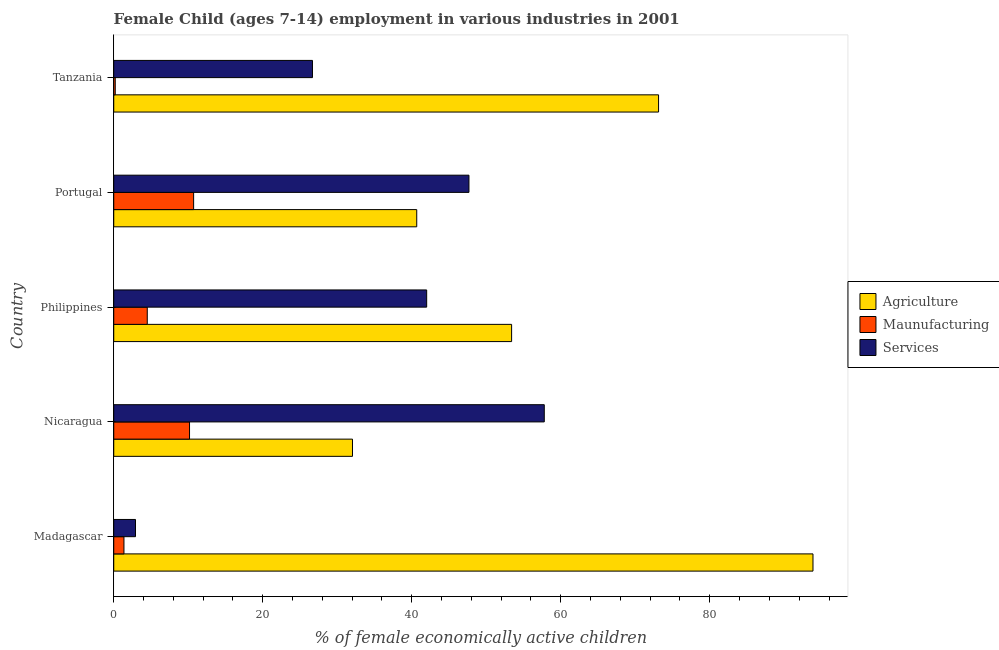Are the number of bars per tick equal to the number of legend labels?
Ensure brevity in your answer.  Yes. Are the number of bars on each tick of the Y-axis equal?
Ensure brevity in your answer.  Yes. What is the label of the 1st group of bars from the top?
Give a very brief answer. Tanzania. In how many cases, is the number of bars for a given country not equal to the number of legend labels?
Ensure brevity in your answer.  0. What is the percentage of economically active children in manufacturing in Portugal?
Ensure brevity in your answer.  10.72. Across all countries, what is the maximum percentage of economically active children in manufacturing?
Offer a very short reply. 10.72. Across all countries, what is the minimum percentage of economically active children in agriculture?
Ensure brevity in your answer.  32.04. In which country was the percentage of economically active children in agriculture maximum?
Give a very brief answer. Madagascar. In which country was the percentage of economically active children in manufacturing minimum?
Ensure brevity in your answer.  Tanzania. What is the total percentage of economically active children in manufacturing in the graph?
Your response must be concise. 26.97. What is the difference between the percentage of economically active children in manufacturing in Madagascar and that in Philippines?
Offer a very short reply. -3.13. What is the difference between the percentage of economically active children in agriculture in Madagascar and the percentage of economically active children in manufacturing in Nicaragua?
Your answer should be compact. 83.68. What is the average percentage of economically active children in manufacturing per country?
Offer a very short reply. 5.39. What is the difference between the percentage of economically active children in agriculture and percentage of economically active children in manufacturing in Tanzania?
Make the answer very short. 72.92. In how many countries, is the percentage of economically active children in agriculture greater than 60 %?
Ensure brevity in your answer.  2. What is the ratio of the percentage of economically active children in manufacturing in Madagascar to that in Philippines?
Keep it short and to the point. 0.3. Is the percentage of economically active children in manufacturing in Philippines less than that in Portugal?
Provide a short and direct response. Yes. Is the difference between the percentage of economically active children in services in Madagascar and Nicaragua greater than the difference between the percentage of economically active children in agriculture in Madagascar and Nicaragua?
Ensure brevity in your answer.  No. What is the difference between the highest and the second highest percentage of economically active children in services?
Make the answer very short. 10.11. What is the difference between the highest and the lowest percentage of economically active children in manufacturing?
Make the answer very short. 10.52. Is the sum of the percentage of economically active children in agriculture in Nicaragua and Portugal greater than the maximum percentage of economically active children in manufacturing across all countries?
Ensure brevity in your answer.  Yes. What does the 2nd bar from the top in Philippines represents?
Your response must be concise. Maunufacturing. What does the 3rd bar from the bottom in Tanzania represents?
Provide a succinct answer. Services. Is it the case that in every country, the sum of the percentage of economically active children in agriculture and percentage of economically active children in manufacturing is greater than the percentage of economically active children in services?
Provide a succinct answer. No. How many bars are there?
Provide a short and direct response. 15. Are all the bars in the graph horizontal?
Make the answer very short. Yes. How many countries are there in the graph?
Keep it short and to the point. 5. Does the graph contain any zero values?
Provide a succinct answer. No. Does the graph contain grids?
Provide a short and direct response. No. How many legend labels are there?
Ensure brevity in your answer.  3. How are the legend labels stacked?
Your answer should be compact. Vertical. What is the title of the graph?
Offer a very short reply. Female Child (ages 7-14) employment in various industries in 2001. Does "Unemployment benefits" appear as one of the legend labels in the graph?
Keep it short and to the point. No. What is the label or title of the X-axis?
Provide a short and direct response. % of female economically active children. What is the % of female economically active children in Agriculture in Madagascar?
Your answer should be very brief. 93.85. What is the % of female economically active children of Maunufacturing in Madagascar?
Make the answer very short. 1.37. What is the % of female economically active children in Services in Madagascar?
Give a very brief answer. 2.92. What is the % of female economically active children in Agriculture in Nicaragua?
Keep it short and to the point. 32.04. What is the % of female economically active children of Maunufacturing in Nicaragua?
Offer a very short reply. 10.17. What is the % of female economically active children of Services in Nicaragua?
Keep it short and to the point. 57.79. What is the % of female economically active children of Agriculture in Philippines?
Offer a very short reply. 53.4. What is the % of female economically active children of Maunufacturing in Philippines?
Make the answer very short. 4.5. What is the % of female economically active children in Services in Philippines?
Your answer should be compact. 42. What is the % of female economically active children of Agriculture in Portugal?
Give a very brief answer. 40.67. What is the % of female economically active children of Maunufacturing in Portugal?
Make the answer very short. 10.72. What is the % of female economically active children in Services in Portugal?
Ensure brevity in your answer.  47.67. What is the % of female economically active children of Agriculture in Tanzania?
Offer a terse response. 73.12. What is the % of female economically active children in Maunufacturing in Tanzania?
Offer a terse response. 0.2. What is the % of female economically active children of Services in Tanzania?
Ensure brevity in your answer.  26.67. Across all countries, what is the maximum % of female economically active children of Agriculture?
Offer a very short reply. 93.85. Across all countries, what is the maximum % of female economically active children of Maunufacturing?
Offer a very short reply. 10.72. Across all countries, what is the maximum % of female economically active children of Services?
Provide a succinct answer. 57.79. Across all countries, what is the minimum % of female economically active children in Agriculture?
Provide a short and direct response. 32.04. Across all countries, what is the minimum % of female economically active children in Maunufacturing?
Give a very brief answer. 0.2. Across all countries, what is the minimum % of female economically active children in Services?
Your answer should be very brief. 2.92. What is the total % of female economically active children of Agriculture in the graph?
Your response must be concise. 293.08. What is the total % of female economically active children in Maunufacturing in the graph?
Offer a very short reply. 26.97. What is the total % of female economically active children in Services in the graph?
Your answer should be very brief. 177.05. What is the difference between the % of female economically active children of Agriculture in Madagascar and that in Nicaragua?
Your answer should be compact. 61.81. What is the difference between the % of female economically active children of Maunufacturing in Madagascar and that in Nicaragua?
Give a very brief answer. -8.8. What is the difference between the % of female economically active children of Services in Madagascar and that in Nicaragua?
Give a very brief answer. -54.87. What is the difference between the % of female economically active children of Agriculture in Madagascar and that in Philippines?
Your response must be concise. 40.45. What is the difference between the % of female economically active children in Maunufacturing in Madagascar and that in Philippines?
Your response must be concise. -3.13. What is the difference between the % of female economically active children in Services in Madagascar and that in Philippines?
Your response must be concise. -39.08. What is the difference between the % of female economically active children in Agriculture in Madagascar and that in Portugal?
Offer a very short reply. 53.18. What is the difference between the % of female economically active children in Maunufacturing in Madagascar and that in Portugal?
Provide a succinct answer. -9.35. What is the difference between the % of female economically active children of Services in Madagascar and that in Portugal?
Offer a very short reply. -44.75. What is the difference between the % of female economically active children of Agriculture in Madagascar and that in Tanzania?
Provide a short and direct response. 20.73. What is the difference between the % of female economically active children of Maunufacturing in Madagascar and that in Tanzania?
Keep it short and to the point. 1.17. What is the difference between the % of female economically active children of Services in Madagascar and that in Tanzania?
Offer a terse response. -23.75. What is the difference between the % of female economically active children of Agriculture in Nicaragua and that in Philippines?
Your response must be concise. -21.36. What is the difference between the % of female economically active children of Maunufacturing in Nicaragua and that in Philippines?
Your response must be concise. 5.67. What is the difference between the % of female economically active children of Services in Nicaragua and that in Philippines?
Make the answer very short. 15.79. What is the difference between the % of female economically active children in Agriculture in Nicaragua and that in Portugal?
Your answer should be compact. -8.62. What is the difference between the % of female economically active children of Maunufacturing in Nicaragua and that in Portugal?
Provide a succinct answer. -0.55. What is the difference between the % of female economically active children in Services in Nicaragua and that in Portugal?
Provide a short and direct response. 10.11. What is the difference between the % of female economically active children of Agriculture in Nicaragua and that in Tanzania?
Your response must be concise. -41.08. What is the difference between the % of female economically active children of Maunufacturing in Nicaragua and that in Tanzania?
Offer a terse response. 9.97. What is the difference between the % of female economically active children of Services in Nicaragua and that in Tanzania?
Your answer should be very brief. 31.11. What is the difference between the % of female economically active children of Agriculture in Philippines and that in Portugal?
Ensure brevity in your answer.  12.73. What is the difference between the % of female economically active children in Maunufacturing in Philippines and that in Portugal?
Your answer should be compact. -6.22. What is the difference between the % of female economically active children of Services in Philippines and that in Portugal?
Give a very brief answer. -5.67. What is the difference between the % of female economically active children in Agriculture in Philippines and that in Tanzania?
Offer a terse response. -19.72. What is the difference between the % of female economically active children in Maunufacturing in Philippines and that in Tanzania?
Your answer should be compact. 4.3. What is the difference between the % of female economically active children of Services in Philippines and that in Tanzania?
Your answer should be very brief. 15.33. What is the difference between the % of female economically active children of Agriculture in Portugal and that in Tanzania?
Provide a succinct answer. -32.46. What is the difference between the % of female economically active children of Maunufacturing in Portugal and that in Tanzania?
Provide a succinct answer. 10.52. What is the difference between the % of female economically active children of Services in Portugal and that in Tanzania?
Your answer should be very brief. 21. What is the difference between the % of female economically active children in Agriculture in Madagascar and the % of female economically active children in Maunufacturing in Nicaragua?
Give a very brief answer. 83.68. What is the difference between the % of female economically active children of Agriculture in Madagascar and the % of female economically active children of Services in Nicaragua?
Give a very brief answer. 36.06. What is the difference between the % of female economically active children in Maunufacturing in Madagascar and the % of female economically active children in Services in Nicaragua?
Offer a very short reply. -56.42. What is the difference between the % of female economically active children of Agriculture in Madagascar and the % of female economically active children of Maunufacturing in Philippines?
Keep it short and to the point. 89.35. What is the difference between the % of female economically active children of Agriculture in Madagascar and the % of female economically active children of Services in Philippines?
Your response must be concise. 51.85. What is the difference between the % of female economically active children in Maunufacturing in Madagascar and the % of female economically active children in Services in Philippines?
Your response must be concise. -40.63. What is the difference between the % of female economically active children of Agriculture in Madagascar and the % of female economically active children of Maunufacturing in Portugal?
Provide a succinct answer. 83.13. What is the difference between the % of female economically active children in Agriculture in Madagascar and the % of female economically active children in Services in Portugal?
Offer a terse response. 46.18. What is the difference between the % of female economically active children in Maunufacturing in Madagascar and the % of female economically active children in Services in Portugal?
Make the answer very short. -46.3. What is the difference between the % of female economically active children of Agriculture in Madagascar and the % of female economically active children of Maunufacturing in Tanzania?
Your answer should be very brief. 93.65. What is the difference between the % of female economically active children of Agriculture in Madagascar and the % of female economically active children of Services in Tanzania?
Offer a very short reply. 67.18. What is the difference between the % of female economically active children of Maunufacturing in Madagascar and the % of female economically active children of Services in Tanzania?
Give a very brief answer. -25.3. What is the difference between the % of female economically active children of Agriculture in Nicaragua and the % of female economically active children of Maunufacturing in Philippines?
Your answer should be compact. 27.54. What is the difference between the % of female economically active children in Agriculture in Nicaragua and the % of female economically active children in Services in Philippines?
Ensure brevity in your answer.  -9.96. What is the difference between the % of female economically active children in Maunufacturing in Nicaragua and the % of female economically active children in Services in Philippines?
Your answer should be very brief. -31.83. What is the difference between the % of female economically active children in Agriculture in Nicaragua and the % of female economically active children in Maunufacturing in Portugal?
Offer a terse response. 21.32. What is the difference between the % of female economically active children in Agriculture in Nicaragua and the % of female economically active children in Services in Portugal?
Offer a terse response. -15.63. What is the difference between the % of female economically active children in Maunufacturing in Nicaragua and the % of female economically active children in Services in Portugal?
Provide a succinct answer. -37.5. What is the difference between the % of female economically active children in Agriculture in Nicaragua and the % of female economically active children in Maunufacturing in Tanzania?
Provide a short and direct response. 31.84. What is the difference between the % of female economically active children in Agriculture in Nicaragua and the % of female economically active children in Services in Tanzania?
Ensure brevity in your answer.  5.37. What is the difference between the % of female economically active children of Maunufacturing in Nicaragua and the % of female economically active children of Services in Tanzania?
Offer a very short reply. -16.5. What is the difference between the % of female economically active children in Agriculture in Philippines and the % of female economically active children in Maunufacturing in Portugal?
Offer a very short reply. 42.68. What is the difference between the % of female economically active children in Agriculture in Philippines and the % of female economically active children in Services in Portugal?
Ensure brevity in your answer.  5.73. What is the difference between the % of female economically active children in Maunufacturing in Philippines and the % of female economically active children in Services in Portugal?
Keep it short and to the point. -43.17. What is the difference between the % of female economically active children in Agriculture in Philippines and the % of female economically active children in Maunufacturing in Tanzania?
Your response must be concise. 53.2. What is the difference between the % of female economically active children of Agriculture in Philippines and the % of female economically active children of Services in Tanzania?
Provide a succinct answer. 26.73. What is the difference between the % of female economically active children in Maunufacturing in Philippines and the % of female economically active children in Services in Tanzania?
Ensure brevity in your answer.  -22.17. What is the difference between the % of female economically active children in Agriculture in Portugal and the % of female economically active children in Maunufacturing in Tanzania?
Your answer should be very brief. 40.46. What is the difference between the % of female economically active children of Agriculture in Portugal and the % of female economically active children of Services in Tanzania?
Your response must be concise. 13.99. What is the difference between the % of female economically active children of Maunufacturing in Portugal and the % of female economically active children of Services in Tanzania?
Your answer should be very brief. -15.95. What is the average % of female economically active children in Agriculture per country?
Your response must be concise. 58.62. What is the average % of female economically active children in Maunufacturing per country?
Your answer should be compact. 5.39. What is the average % of female economically active children in Services per country?
Give a very brief answer. 35.41. What is the difference between the % of female economically active children of Agriculture and % of female economically active children of Maunufacturing in Madagascar?
Give a very brief answer. 92.48. What is the difference between the % of female economically active children of Agriculture and % of female economically active children of Services in Madagascar?
Your response must be concise. 90.93. What is the difference between the % of female economically active children of Maunufacturing and % of female economically active children of Services in Madagascar?
Offer a terse response. -1.55. What is the difference between the % of female economically active children of Agriculture and % of female economically active children of Maunufacturing in Nicaragua?
Your response must be concise. 21.87. What is the difference between the % of female economically active children of Agriculture and % of female economically active children of Services in Nicaragua?
Provide a short and direct response. -25.74. What is the difference between the % of female economically active children of Maunufacturing and % of female economically active children of Services in Nicaragua?
Ensure brevity in your answer.  -47.61. What is the difference between the % of female economically active children in Agriculture and % of female economically active children in Maunufacturing in Philippines?
Your answer should be very brief. 48.9. What is the difference between the % of female economically active children of Maunufacturing and % of female economically active children of Services in Philippines?
Ensure brevity in your answer.  -37.5. What is the difference between the % of female economically active children of Agriculture and % of female economically active children of Maunufacturing in Portugal?
Provide a short and direct response. 29.94. What is the difference between the % of female economically active children of Agriculture and % of female economically active children of Services in Portugal?
Keep it short and to the point. -7.01. What is the difference between the % of female economically active children of Maunufacturing and % of female economically active children of Services in Portugal?
Offer a very short reply. -36.95. What is the difference between the % of female economically active children in Agriculture and % of female economically active children in Maunufacturing in Tanzania?
Keep it short and to the point. 72.92. What is the difference between the % of female economically active children of Agriculture and % of female economically active children of Services in Tanzania?
Give a very brief answer. 46.45. What is the difference between the % of female economically active children in Maunufacturing and % of female economically active children in Services in Tanzania?
Provide a short and direct response. -26.47. What is the ratio of the % of female economically active children in Agriculture in Madagascar to that in Nicaragua?
Your answer should be very brief. 2.93. What is the ratio of the % of female economically active children in Maunufacturing in Madagascar to that in Nicaragua?
Your answer should be very brief. 0.13. What is the ratio of the % of female economically active children of Services in Madagascar to that in Nicaragua?
Provide a succinct answer. 0.05. What is the ratio of the % of female economically active children in Agriculture in Madagascar to that in Philippines?
Ensure brevity in your answer.  1.76. What is the ratio of the % of female economically active children in Maunufacturing in Madagascar to that in Philippines?
Offer a terse response. 0.3. What is the ratio of the % of female economically active children in Services in Madagascar to that in Philippines?
Provide a short and direct response. 0.07. What is the ratio of the % of female economically active children of Agriculture in Madagascar to that in Portugal?
Give a very brief answer. 2.31. What is the ratio of the % of female economically active children in Maunufacturing in Madagascar to that in Portugal?
Provide a succinct answer. 0.13. What is the ratio of the % of female economically active children of Services in Madagascar to that in Portugal?
Make the answer very short. 0.06. What is the ratio of the % of female economically active children in Agriculture in Madagascar to that in Tanzania?
Keep it short and to the point. 1.28. What is the ratio of the % of female economically active children of Maunufacturing in Madagascar to that in Tanzania?
Give a very brief answer. 6.75. What is the ratio of the % of female economically active children in Services in Madagascar to that in Tanzania?
Keep it short and to the point. 0.11. What is the ratio of the % of female economically active children in Agriculture in Nicaragua to that in Philippines?
Offer a terse response. 0.6. What is the ratio of the % of female economically active children in Maunufacturing in Nicaragua to that in Philippines?
Your answer should be very brief. 2.26. What is the ratio of the % of female economically active children of Services in Nicaragua to that in Philippines?
Provide a succinct answer. 1.38. What is the ratio of the % of female economically active children of Agriculture in Nicaragua to that in Portugal?
Provide a succinct answer. 0.79. What is the ratio of the % of female economically active children in Maunufacturing in Nicaragua to that in Portugal?
Your response must be concise. 0.95. What is the ratio of the % of female economically active children of Services in Nicaragua to that in Portugal?
Keep it short and to the point. 1.21. What is the ratio of the % of female economically active children in Agriculture in Nicaragua to that in Tanzania?
Provide a short and direct response. 0.44. What is the ratio of the % of female economically active children in Maunufacturing in Nicaragua to that in Tanzania?
Provide a succinct answer. 50.1. What is the ratio of the % of female economically active children of Services in Nicaragua to that in Tanzania?
Make the answer very short. 2.17. What is the ratio of the % of female economically active children of Agriculture in Philippines to that in Portugal?
Provide a succinct answer. 1.31. What is the ratio of the % of female economically active children of Maunufacturing in Philippines to that in Portugal?
Offer a very short reply. 0.42. What is the ratio of the % of female economically active children of Services in Philippines to that in Portugal?
Provide a short and direct response. 0.88. What is the ratio of the % of female economically active children in Agriculture in Philippines to that in Tanzania?
Ensure brevity in your answer.  0.73. What is the ratio of the % of female economically active children of Maunufacturing in Philippines to that in Tanzania?
Your response must be concise. 22.16. What is the ratio of the % of female economically active children in Services in Philippines to that in Tanzania?
Offer a terse response. 1.57. What is the ratio of the % of female economically active children in Agriculture in Portugal to that in Tanzania?
Offer a very short reply. 0.56. What is the ratio of the % of female economically active children of Maunufacturing in Portugal to that in Tanzania?
Your answer should be very brief. 52.81. What is the ratio of the % of female economically active children of Services in Portugal to that in Tanzania?
Make the answer very short. 1.79. What is the difference between the highest and the second highest % of female economically active children in Agriculture?
Offer a very short reply. 20.73. What is the difference between the highest and the second highest % of female economically active children in Maunufacturing?
Make the answer very short. 0.55. What is the difference between the highest and the second highest % of female economically active children of Services?
Ensure brevity in your answer.  10.11. What is the difference between the highest and the lowest % of female economically active children of Agriculture?
Provide a succinct answer. 61.81. What is the difference between the highest and the lowest % of female economically active children of Maunufacturing?
Your answer should be very brief. 10.52. What is the difference between the highest and the lowest % of female economically active children in Services?
Your answer should be very brief. 54.87. 